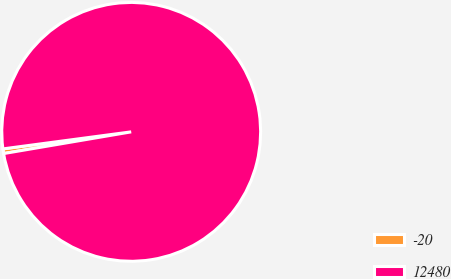Convert chart. <chart><loc_0><loc_0><loc_500><loc_500><pie_chart><fcel>-20<fcel>12480<nl><fcel>0.58%<fcel>99.42%<nl></chart> 